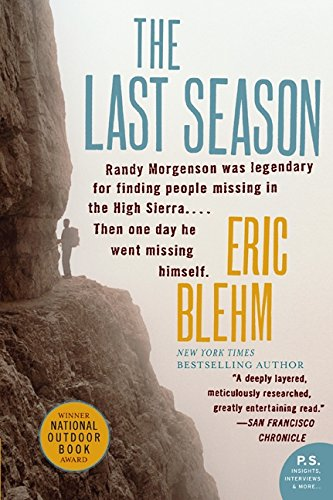How did Randy Morgenson become legendary? Randy Morgenson became legendary due to his dedication and skill in rescuing and searching for missing persons in the difficult terrains of the Sierra Nevada over many years. What led to his disappearance? Randy Morgenson's disappearance remains somewhat mysterious, but it is speculated to be related to the challenging and risky nature of his work in the vast wilderness of the high Sierra. 